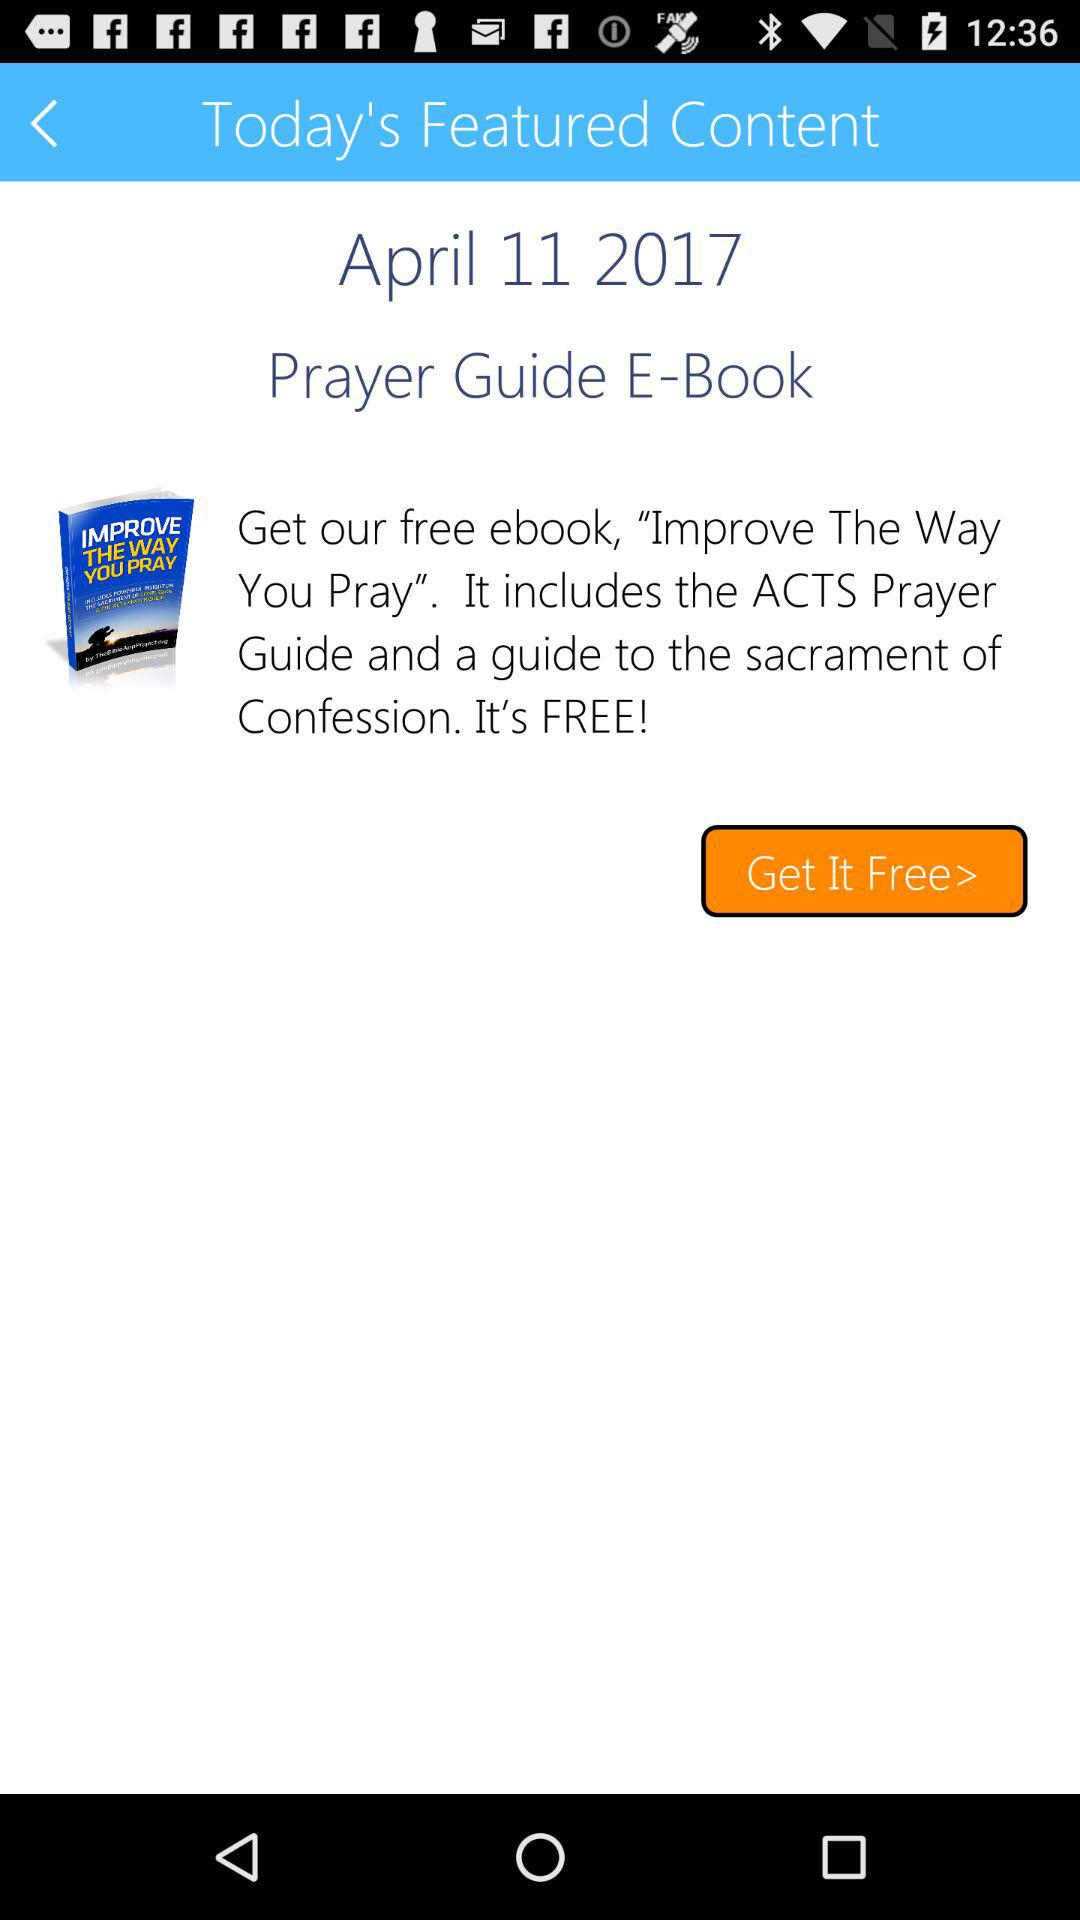What is the application name?
When the provided information is insufficient, respond with <no answer>. <no answer> 